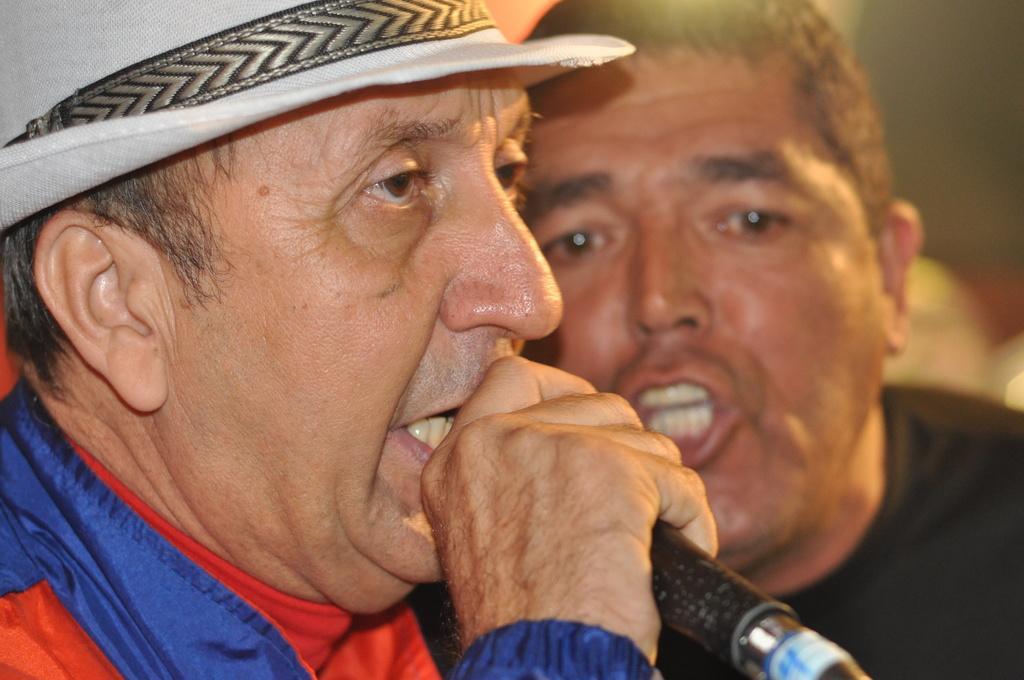Please provide a concise description of this image. in this picture there are two persons together,one person is talking in microphone by catching it with his hand. 